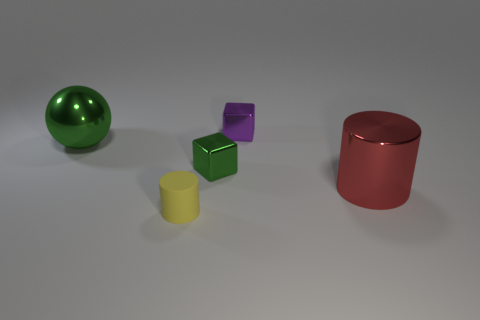There is a thing that is in front of the green shiny cube and behind the yellow matte object; what is its size?
Provide a succinct answer. Large. How many matte things are either cubes or big cylinders?
Offer a terse response. 0. What is the small yellow cylinder made of?
Offer a terse response. Rubber. What is the big thing that is right of the large shiny thing that is on the left side of the block that is in front of the big green metal ball made of?
Provide a succinct answer. Metal. There is a green object that is the same size as the purple shiny thing; what shape is it?
Provide a succinct answer. Cube. How many objects are red metallic objects or small things in front of the green metallic ball?
Offer a very short reply. 3. Is the material of the tiny cylinder in front of the purple metal thing the same as the cube behind the green metal cube?
Provide a succinct answer. No. The metallic thing that is the same color as the big sphere is what shape?
Offer a very short reply. Cube. What number of purple things are big shiny things or small matte cylinders?
Provide a short and direct response. 0. The rubber object is what size?
Make the answer very short. Small. 